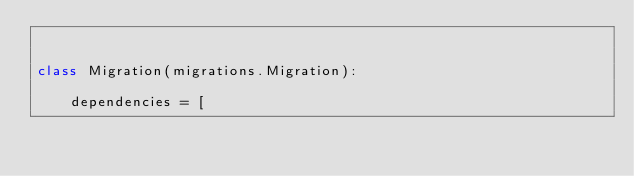<code> <loc_0><loc_0><loc_500><loc_500><_Python_>

class Migration(migrations.Migration):

    dependencies = [</code> 